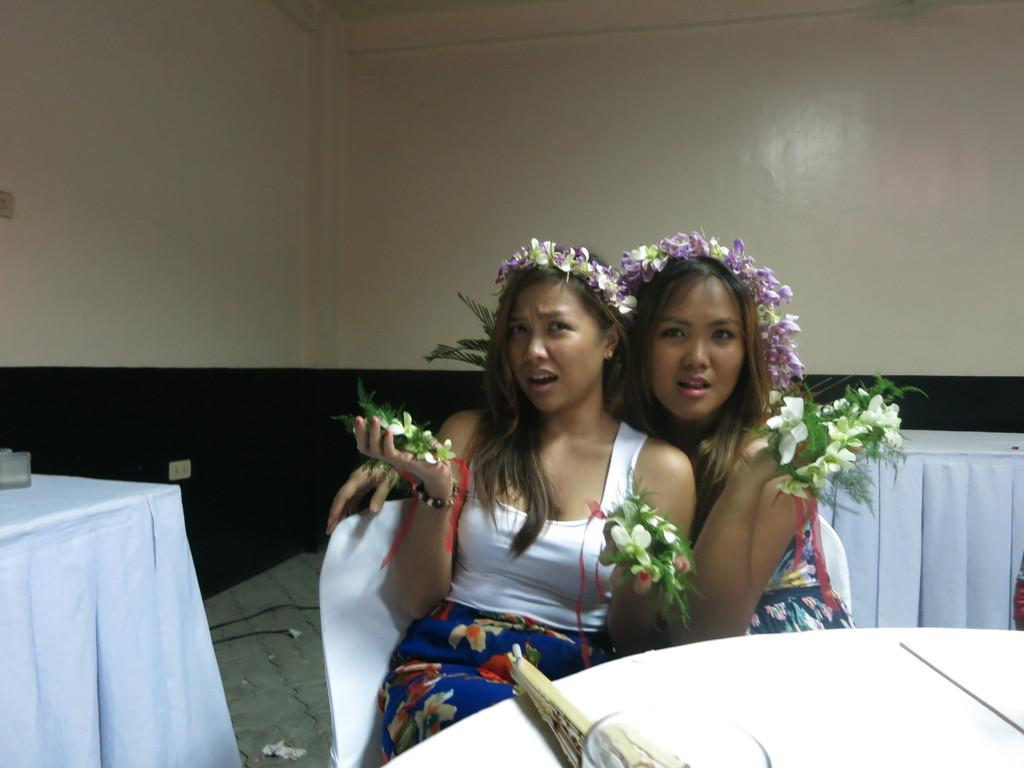How many women are in the image? There are 2 women in the image. What are the women wearing on their heads? The women are wearing headgear. What are the women holding in their hands? The women are holding flowers in their hands. What are the women sitting on in the image? The women are sitting on chairs. What piece of furniture is present in the image? There is a table in the image. Where is the playground located in the image? There is no playground present in the image. 